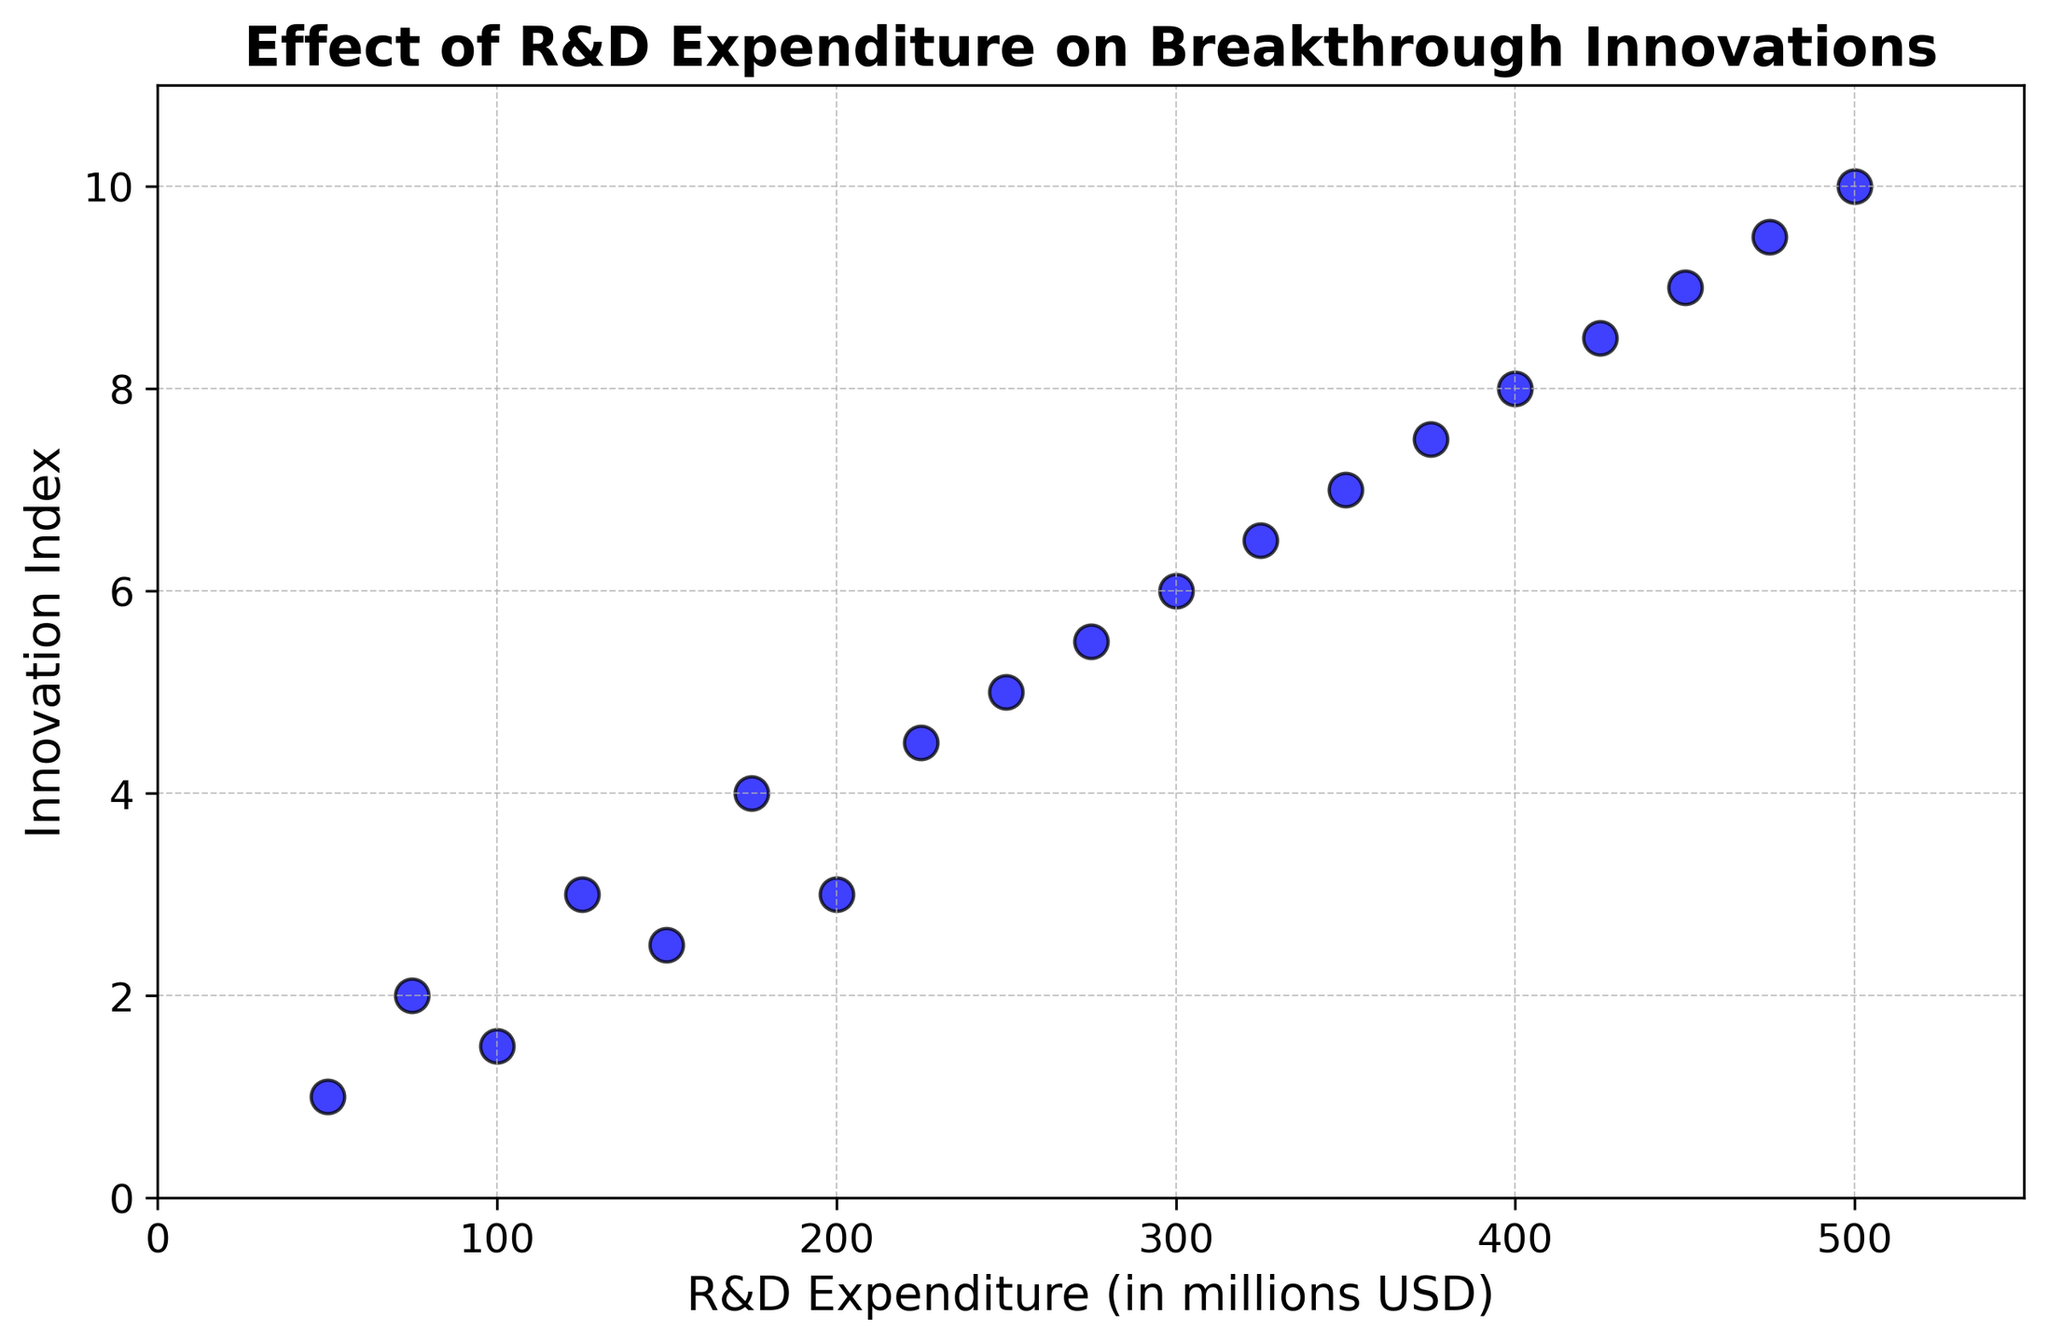What's the minimum Innovation Index value and its corresponding R&D Expenditure? The scatter plot shows the lowest Innovation Index as 1. Referring to the x-axis, the corresponding R&D Expenditure is 50 million USD.
Answer: 50 million USD What's the maximum Innovation Index and its corresponding R&D Expenditure? The highest Innovation Index observed in the scatter plot is 10. The corresponding R&D Expenditure is 500 million USD according to the x-axis.
Answer: 500 million USD What is the average Innovation Index for R&D Expenditures of 150 million USD, 200 million USD, and 250 million USD? Identify the Innovation Index values for these R&D Expenditures (2.5, 3, 5). Sum them up (2.5 + 3 + 5 = 10.5) and then divide by 3 for the average (10.5 / 3 = 3.5).
Answer: 3.5 Which R&D Expenditure levels correspond to an Innovation Index of 4? There are two data points with an Innovation Index of 4. Referring to the x-axis, the R&D Expenditure levels are 175 million USD and 225 million USD.
Answer: 175 million USD, 225 million USD How does the Innovation Index trend as R&D Expenditure increases from 50 million USD to 500 million USD? The Innovation Index shows a positive trend. As the R&D Expenditure increases from 50 million USD to 500 million USD, the Innovation Index increases from 1 to 10.
Answer: Positive trend Which R&D Expenditure has a higher Innovation Index: 300 million USD or 350 million USD? At 300 million USD, the Innovation Index is 6. At 350 million USD, the Innovation Index is 7. 7 is greater than 6.
Answer: 350 million USD What is the difference in the Innovation Index between the lowest and highest R&D Expenditure? The lowest Innovation Index is 1 (at 50 million USD) and the highest is 10 (at 500 million USD). The difference is 10 - 1 = 9.
Answer: 9 Is there a significant increase in Innovation Index between R&D Expenditures of 100 million USD and 125 million USD? At 100 million USD, the Innovation Index is 1.5. At 125 million USD, it is 3. The increase is 3 - 1.5 = 1.5, which is significant relative to the scale of changes.
Answer: Yes For R&D Expenditures of 400 million USD and 450 million USD, which has a higher Innovation Index? At 400 million USD, the Innovation Index is 8. At 450 million USD, the Innovation Index is 9. 9 is higher than 8.
Answer: 450 million USD What can you infer about the overall relationship between R&D Expenditure and the Innovation Index? The scatter plot depicts a clear positive trend: as R&D Expenditure increases, the Innovation Index also increases, indicating a strong positive correlation between R&D investment and innovation.
Answer: Positive correlation 